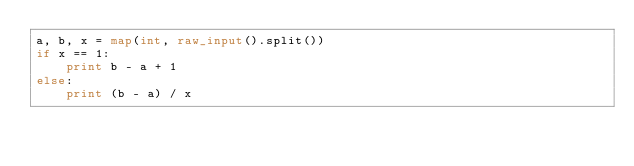Convert code to text. <code><loc_0><loc_0><loc_500><loc_500><_Python_>a, b, x = map(int, raw_input().split())
if x == 1:
    print b - a + 1
else:
    print (b - a) / x</code> 